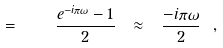<formula> <loc_0><loc_0><loc_500><loc_500>= \quad \frac { e ^ { - i \pi \omega } - 1 } 2 \ \approx \ \frac { - i \pi \omega } 2 \ ,</formula> 